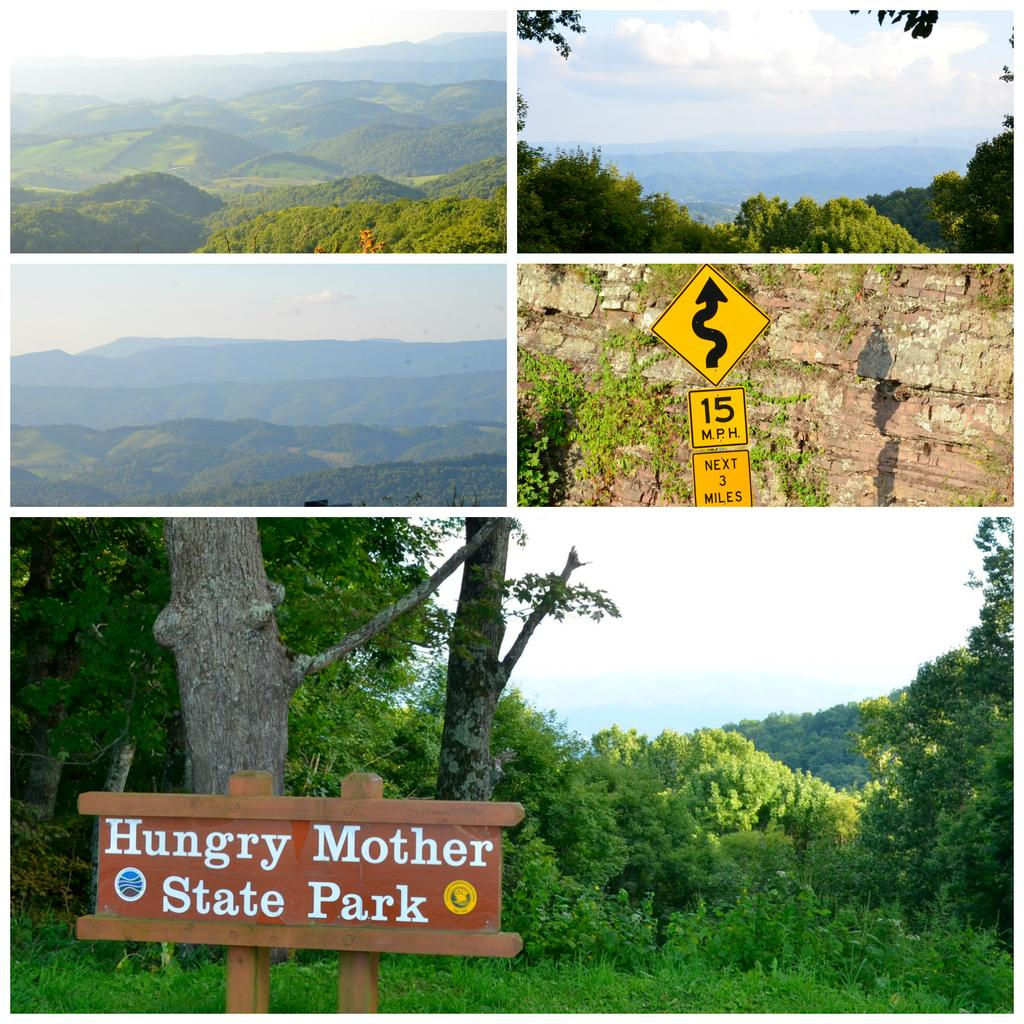What type of natural formation can be seen in the image? There are mountains in the image. What other objects are present in the image? There are trees with name boards, rocks, and sign boards in front of the rocks. What is visible in the sky in the image? There are clouds in the sky. Where is the downtown area located in the image? There is no downtown area present in the image. Can you spot a rabbit hiding among the rocks in the image? There is no rabbit present in the image. 